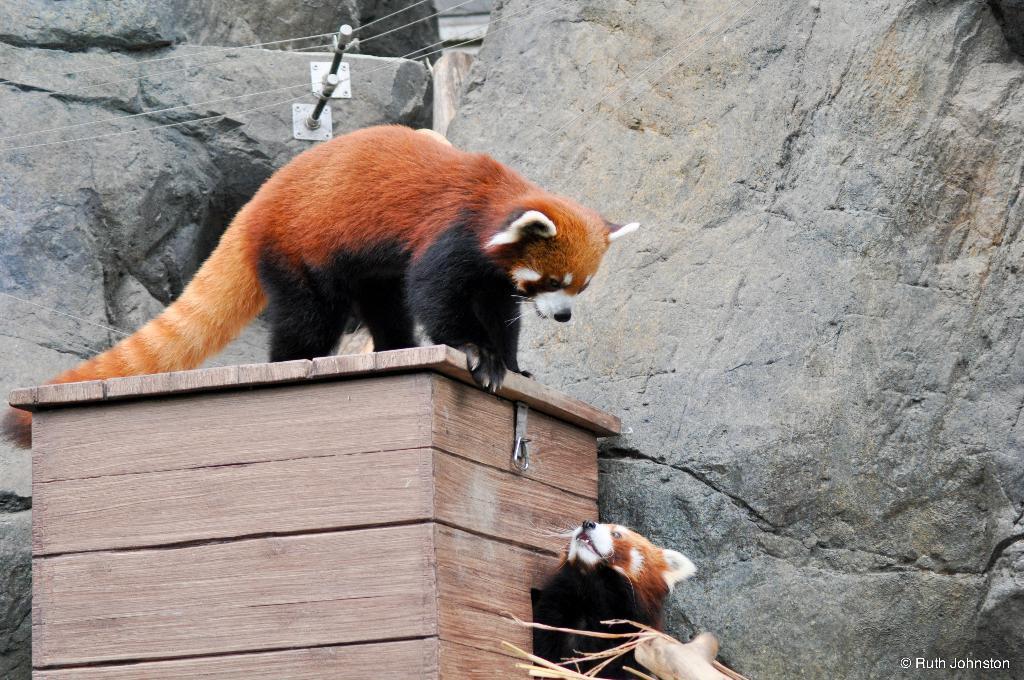In one or two sentences, can you explain what this image depicts? In this picture there is an animal standing on the wooden object and there is an animal beside the wooden object. In the foreground it looks like a tree branch. At the back it looks like a hill and there are wires on the rods. 